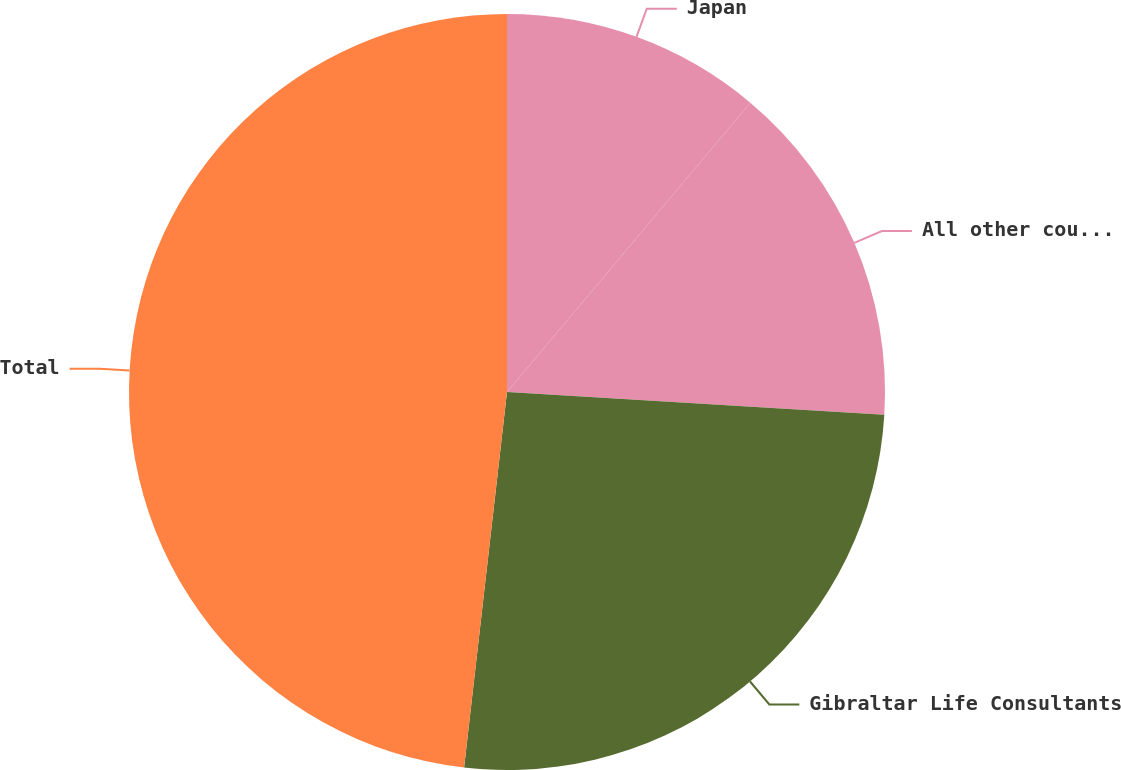Convert chart to OTSL. <chart><loc_0><loc_0><loc_500><loc_500><pie_chart><fcel>Japan<fcel>All other countries<fcel>Gibraltar Life Consultants<fcel>Total<nl><fcel>11.13%<fcel>14.83%<fcel>25.85%<fcel>48.19%<nl></chart> 